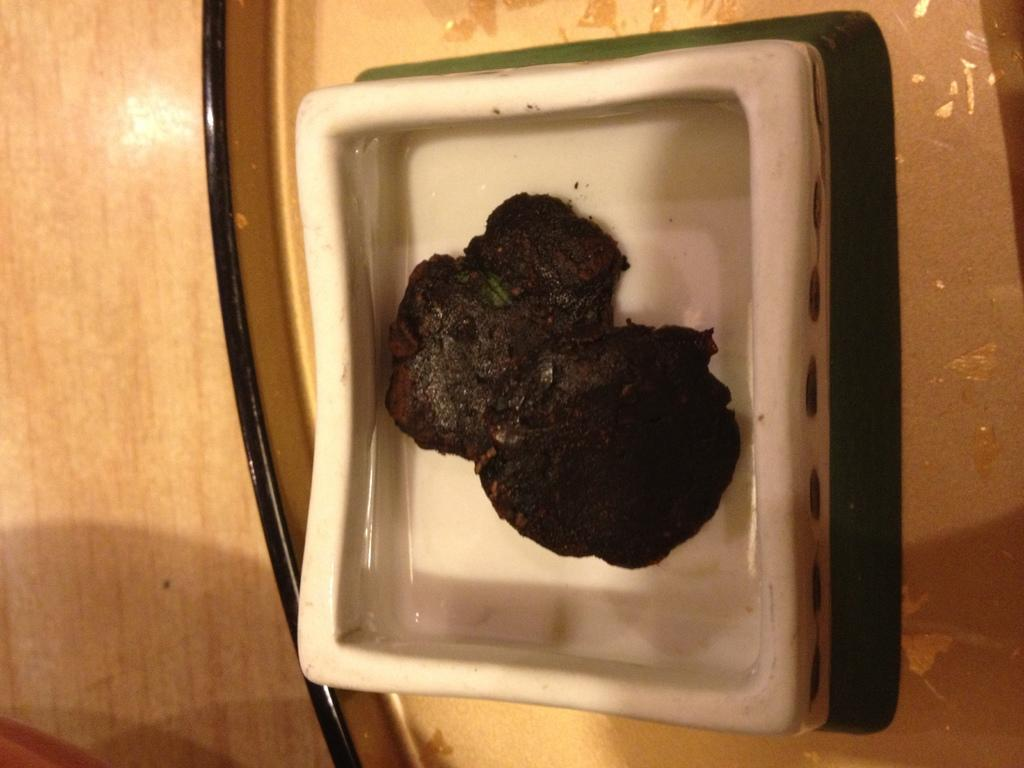What is on the plate that is visible in the image? There is food served in a plate in the image. How is the plate positioned in the image? The plate is placed in a tray. What type of surface is the tray placed on? The tray is placed on a wooden table. What type of sign can be seen hanging from the wooden table in the image? There is no sign hanging from the wooden table in the image; it only features a tray with a plate of food. 